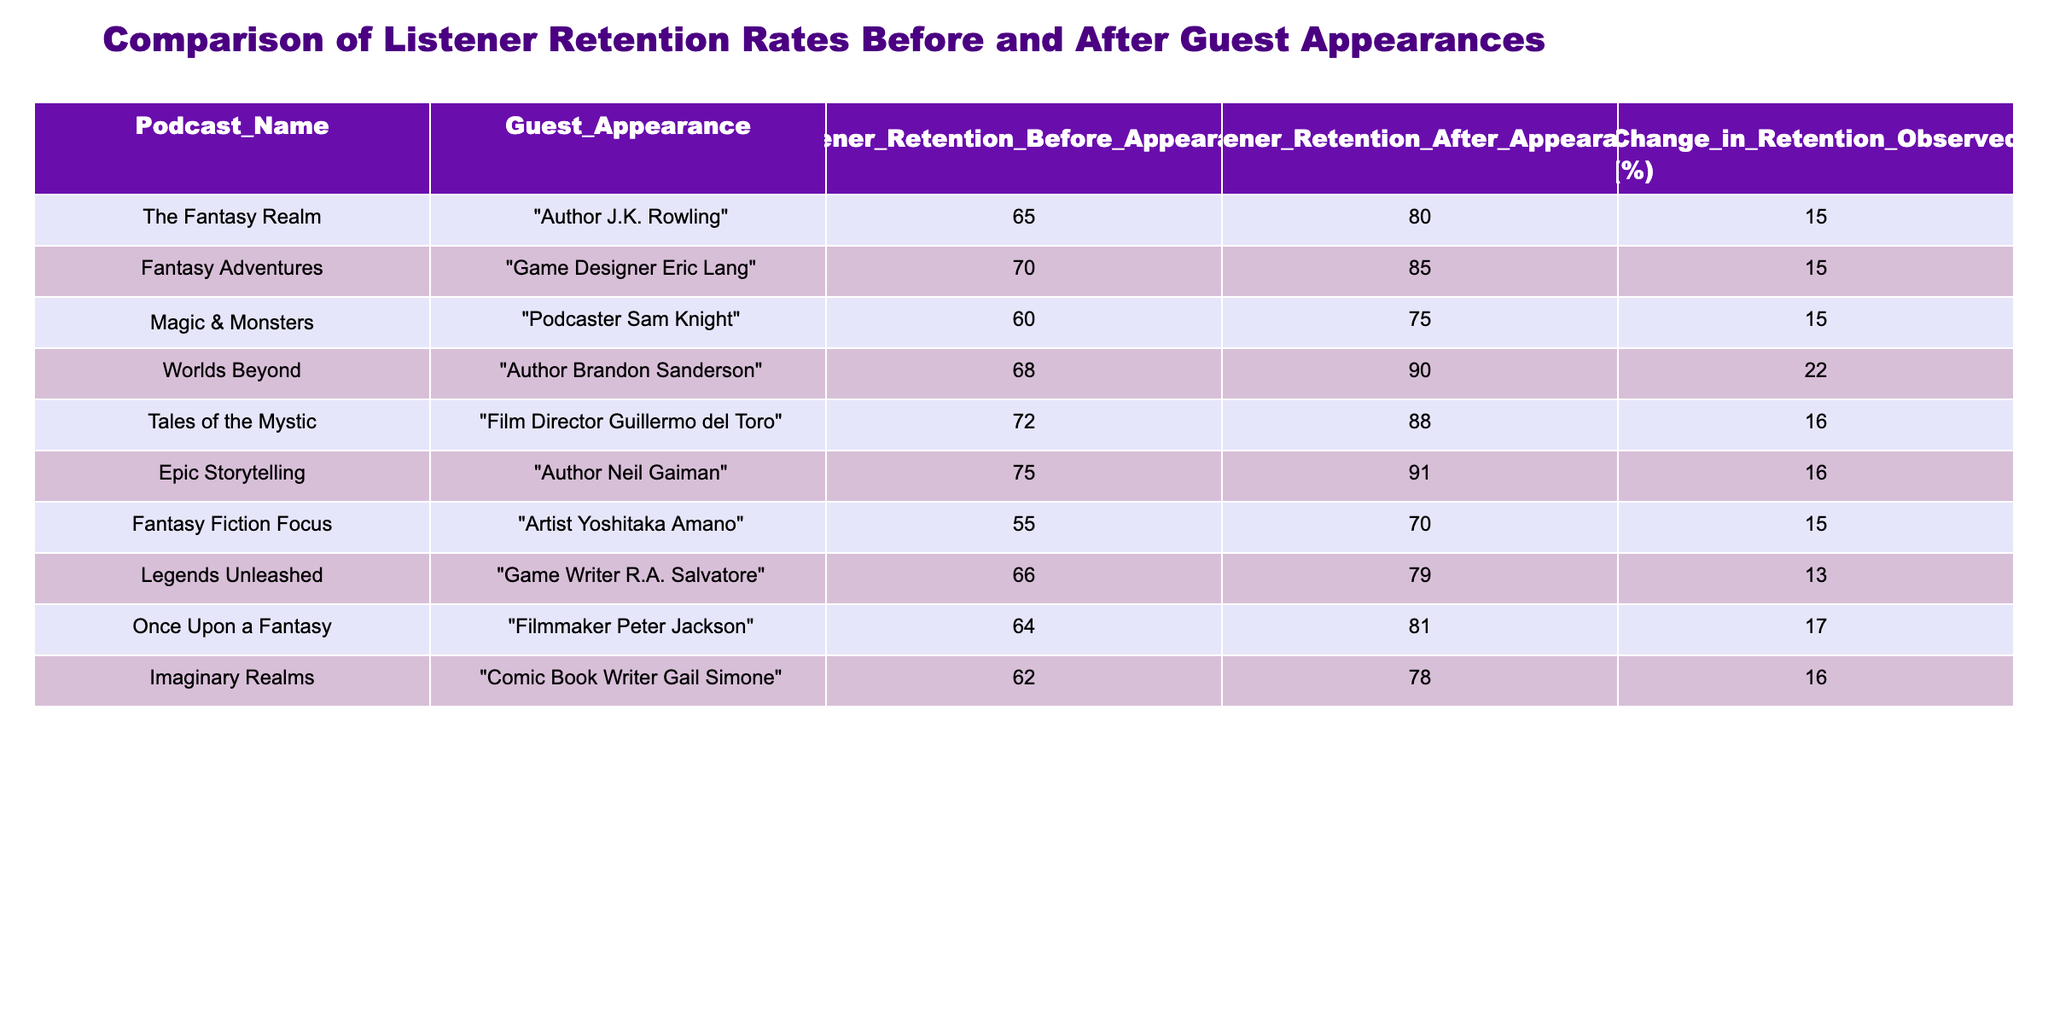What was the listener retention rate for "Worlds Beyond" before the guest appearance? The table shows the listener retention rate for various podcasts before and after guest appearances. For "Worlds Beyond," the retention rate before the guest appearance, which is listed in the corresponding column, is 68%.
Answer: 68% Which podcast showed the largest increase in listener retention after the guest appearance? To find the largest increase, we can look at the "Change in Retention Observed" column. The highest value in that column is 22%, which corresponds to "Worlds Beyond." Thus, this podcast saw the most significant increment in retention after the guest appearance.
Answer: "Worlds Beyond" What is the average listener retention rate after the guest appearances across all podcasts? The average can be found by adding all the listener retention rates after guest appearances (80 + 85 + 75 + 90 + 88 + 91 + 70 + 79 + 81 + 78 = 835) and then dividing by the number of podcasts (10). 835 / 10 = 83.5.
Answer: 83.5% Is the listener retention rate after the guest appearance for "Epic Storytelling" greater than 90%? By referring to the table, the listener retention rate after the guest appearance for "Epic Storytelling" is 91%, which is indeed greater than 90%.
Answer: Yes What is the difference in listener retention rates before and after guest appearances for "Tales of the Mystic"? The listener retention rate before the guest appearance is 72% and after is 88%. The difference is calculated as 88 - 72 = 16%.
Answer: 16% How many podcasts had a listener retention rate after the guest appearance of 85% or higher? We can count the entries in the "Listener Retention After Appearance (%)" column that are 85% or above. The qualifying podcasts are "Fantasy Adventures" (85%), "Worlds Beyond" (90%), "Tales of the Mystic" (88%), "Epic Storytelling" (91%), leading to a total of 4 podcasts.
Answer: 4 Did the listener retention rate decline for any podcast after the guest appearance? Looking through the "Listener Retention After Appearance (%)" column compared to the "Listener Retention Before Appearance (%)", there are no declines observed, meaning all rates increased.
Answer: No Which guest appearance resulted in a 15% increase in listener retention? By examining the "Change in Retention Observed (%)" column, we see that "The Fantasy Realm", "Fantasy Adventures", "Magic & Monsters", "Fantasy Fiction Focus", and "Imaginary Realms" all had a 15% increase, indicating five podcasts achieved this specific change.
Answer: "The Fantasy Realm", "Fantasy Adventures", "Magic & Monsters", "Fantasy Fiction Focus", "Imaginary Realms" 